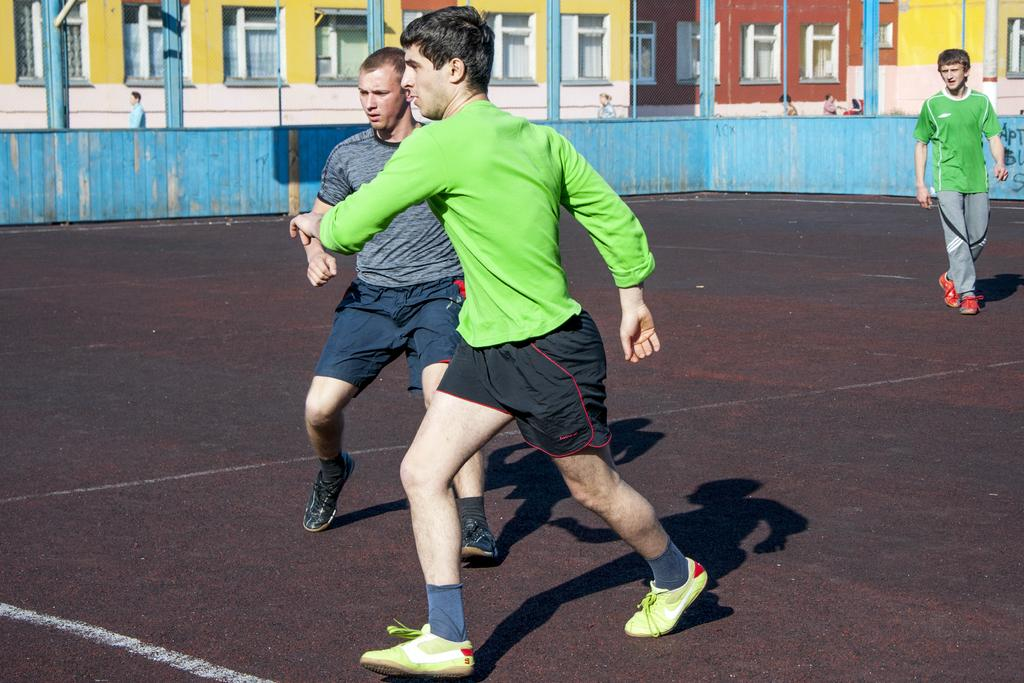Who or what is present in the image? There are people in the image. What are the people doing in the image? The people are playing on the ground. What can be seen in the distance behind the people? There are buildings visible in the background of the image. What type of flag is being waved by the people in the image? There is no flag visible in the image; the people are playing on the ground without any flags. 